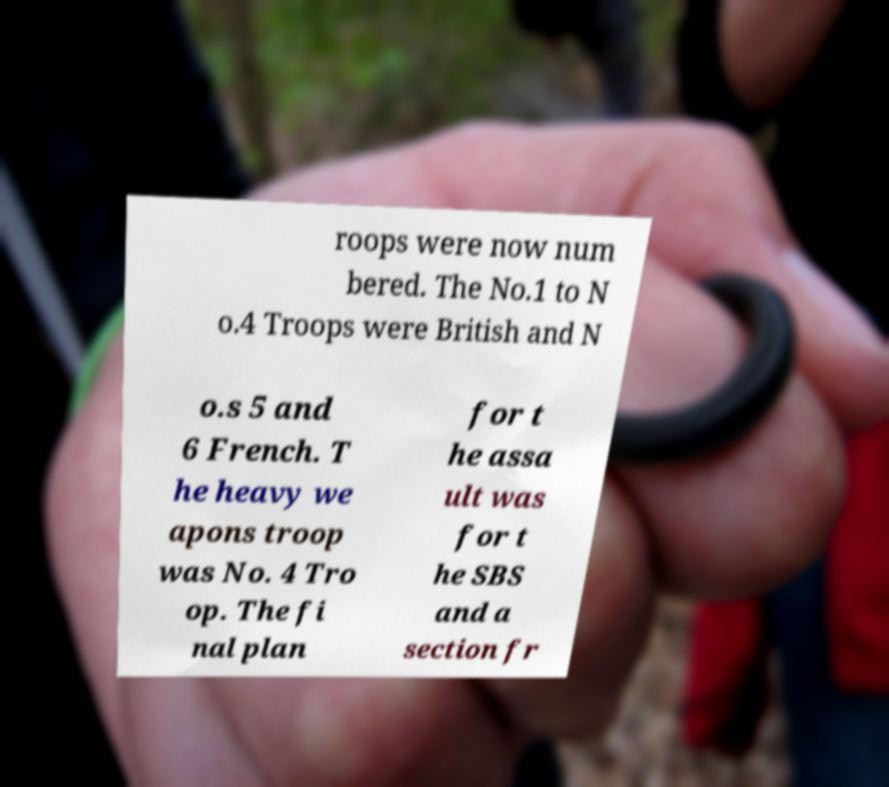Can you accurately transcribe the text from the provided image for me? roops were now num bered. The No.1 to N o.4 Troops were British and N o.s 5 and 6 French. T he heavy we apons troop was No. 4 Tro op. The fi nal plan for t he assa ult was for t he SBS and a section fr 